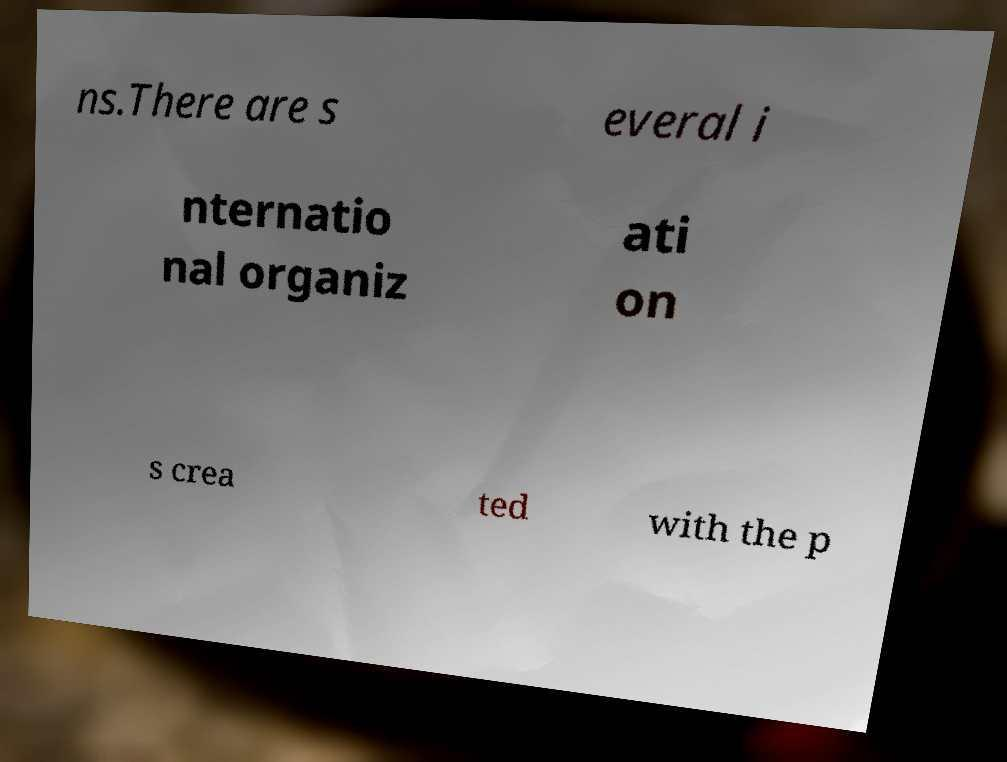There's text embedded in this image that I need extracted. Can you transcribe it verbatim? ns.There are s everal i nternatio nal organiz ati on s crea ted with the p 